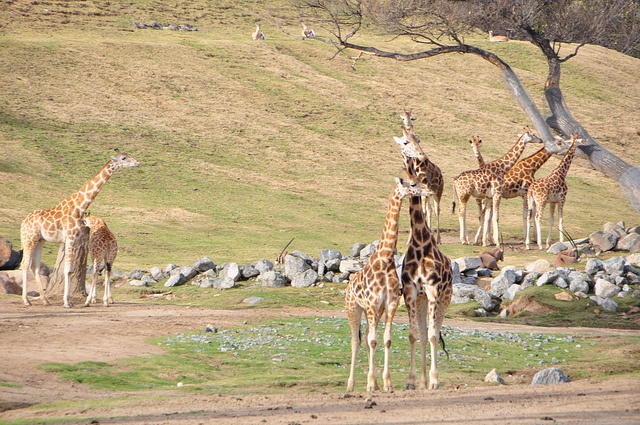Describe the objects in this image and their specific colors. I can see giraffe in gray, tan, ivory, and black tones, giraffe in gray, ivory, and tan tones, giraffe in gray, ivory, and tan tones, giraffe in gray, ivory, and tan tones, and giraffe in gray, ivory, and tan tones in this image. 